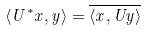<formula> <loc_0><loc_0><loc_500><loc_500>\langle U ^ { * } x , y \rangle = \overline { \langle x , U y \rangle }</formula> 